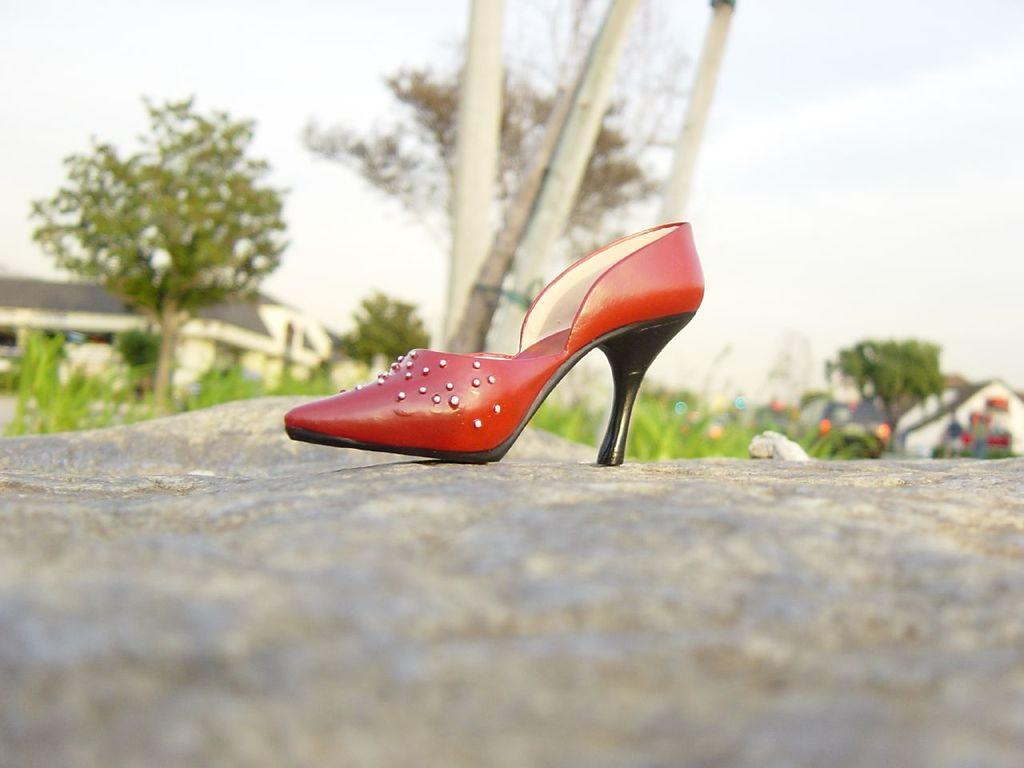What type of footwear is visible in the image? There is footwear in the image. Where is the footwear placed? The footwear is on a rock surface. What can be seen in the background of the image? There is grass, trees, houses, and the sky visible in the background of the image. What type of skirt is the robin wearing in the image? There is no robin or skirt present in the image. Can you describe the flight of the bird in the image? There is no bird visible in the image, so it is not possible to describe its flight. 